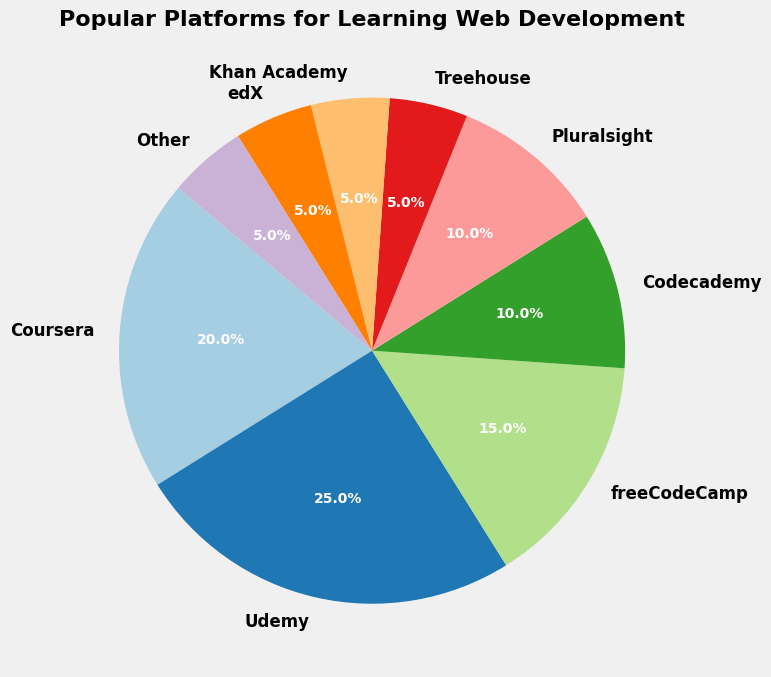Which platform has the largest percentage? Looking at the pie chart, we find the largest wedge which corresponds to Udemy. The label shows 25%, indicating it has the largest percentage.
Answer: Udemy What is the total percentage of platforms with a 5% share? In the chart, Treehouse, Khan Academy, edX, and 'Other' each have a 5% share. Summing them up: 5% + 5% + 5% + 5% = 20%.
Answer: 20% Are there more platforms with shares above or equal to 10% or below 10%? Platforms with shares above or equal to 10% are Coursera (20%), Udemy (25%), freeCodeCamp (15%), Codecademy (10%), and Pluralsight (10%), totaling 5 platforms. Platforms with shares below 10% are Treehouse, Khan Academy, edX, and 'Other,' totaling 4 platforms.
Answer: Above or equal to 10% Which platforms share the same percentage? Looking at the chart, Pluralsight, Codecademy, and 'Other' all have 10%. The labels on the chart confirm this.
Answer: Pluralsight and Codecademy What percentage of web development learning is represented by Coursera, freeCodeCamp, and Udemy together? Summing the percentages from the chart: Coursera (20%) + freeCodeCamp (15%) + Udemy (25%) = 60%.
Answer: 60% If another platform had a 6% share, would it fall within the top 5 platforms by share? The current top 5 are Udemy (25%), Coursera (20%), freeCodeCamp (15%), Codecademy (10%), and Pluralsight (10%). Adding another platform with a 6% share would still place it below the top 5, which have shares of at least 10%.
Answer: No What is the difference in percentage share between the most and least popular platforms? The most popular platform is Udemy with 25%, and the least popular platforms are Treehouse, Khan Academy, edX, and 'Other,' each with 5%. The difference is 25% - 5% = 20%.
Answer: 20% Does freeCodeCamp have more share than all platforms with 5% share combined? freeCodeCamp has a 15% share. Platforms with 5% share are Treehouse, Khan Academy, edX, and 'Other,' which combined total 20%. 15% < 20%, so freeCodeCamp has less share.
Answer: No 